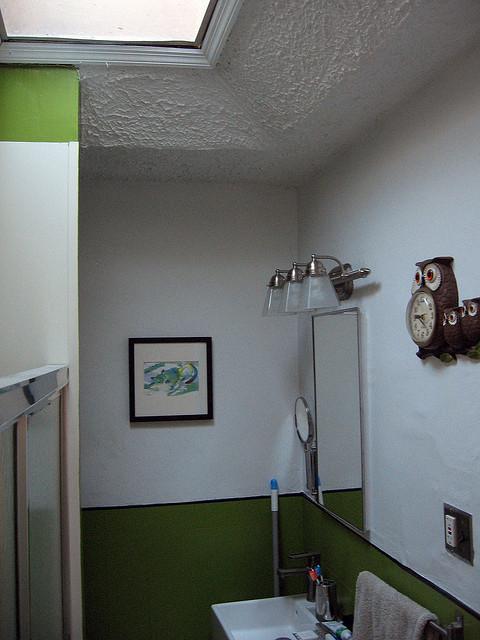How many toothbrushes are in this photo?
Be succinct. 2. What kind of stuffed animal is that?
Write a very short answer. Owl. Does folklore suggest an animal depicted here is wise?
Short answer required. Yes. What color is the wall?
Write a very short answer. White. What is hanging on the rack near the sink?
Quick response, please. Towel. What is the picture on the wall?
Quick response, please. Abstract. How many pictures are on the wall?
Be succinct. 1. Is this bathroom appropriate?
Write a very short answer. Yes. 